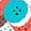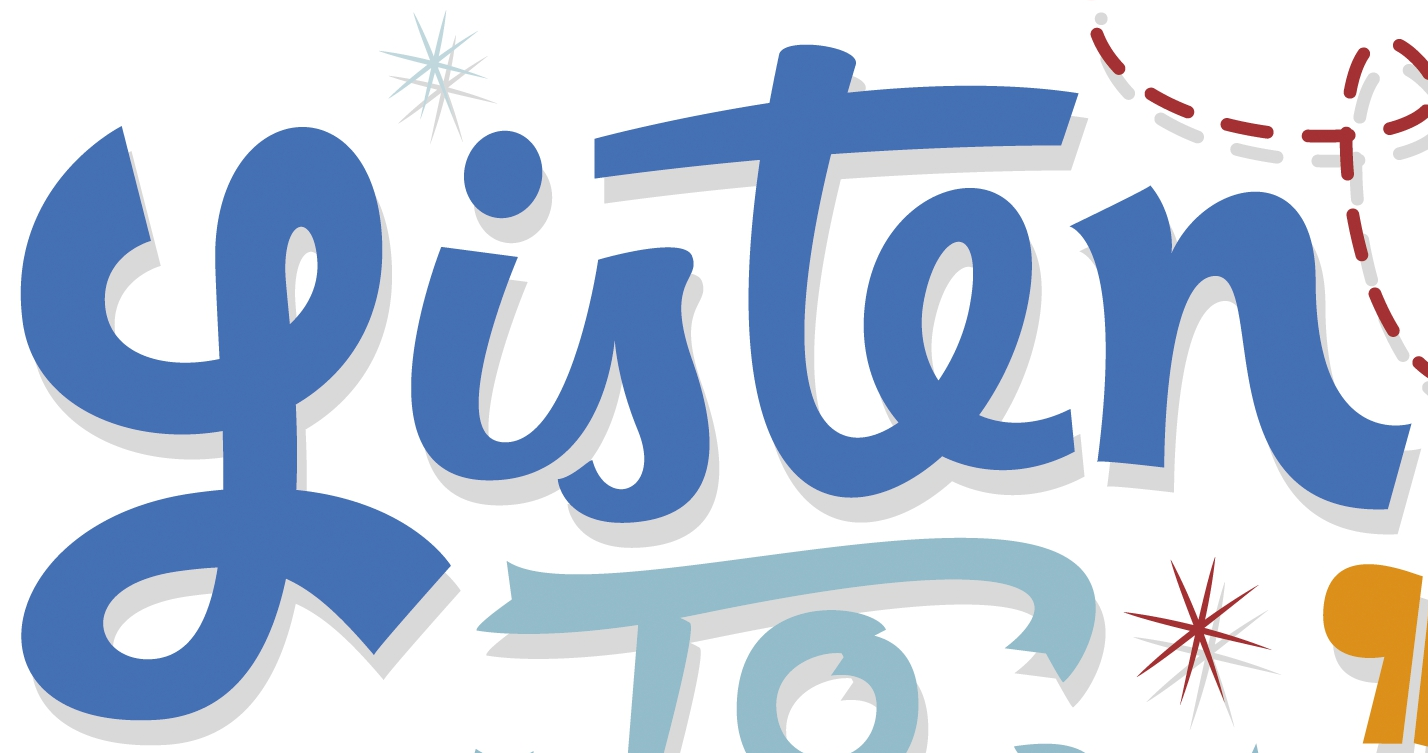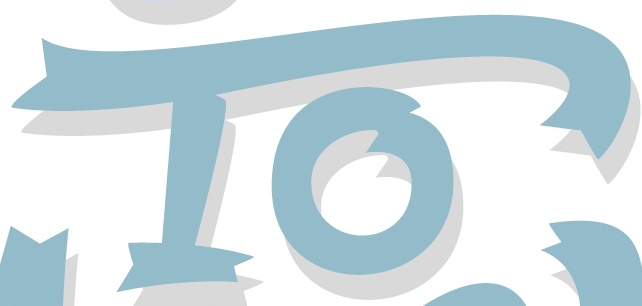What text is displayed in these images sequentially, separated by a semicolon? .; Listen; To 